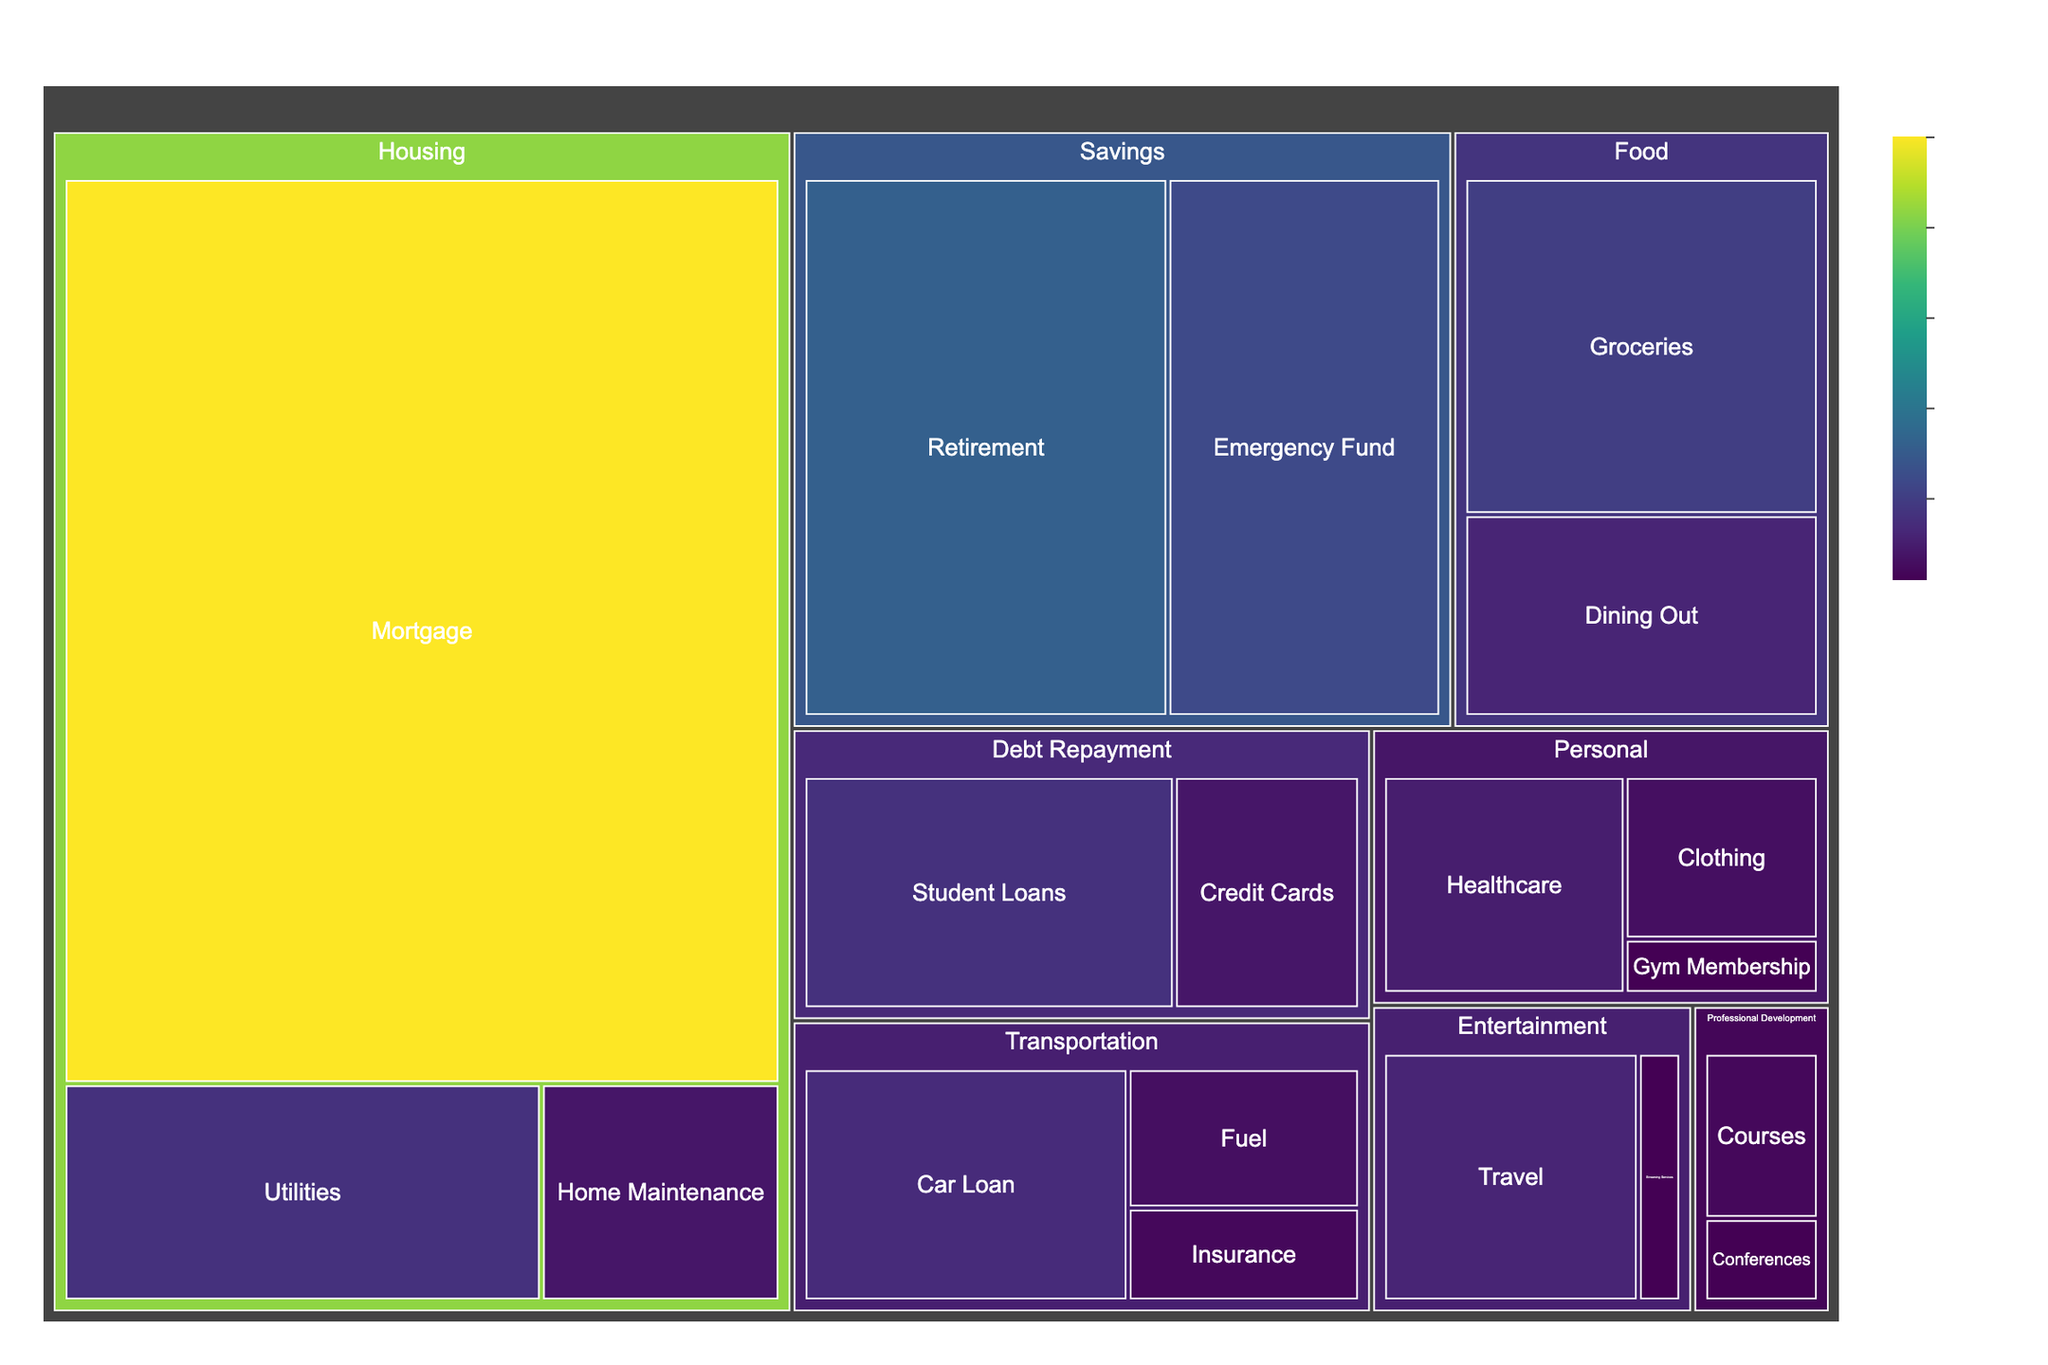What is the largest category in terms of finance allocation? To determine the largest category, look for the segment in the Treemap labeled with the most extensive section. In this case, the largest section is 'Housing.'
Answer: Housing What is the total allocation towards the Housing category? Within the Housing category, sum up the values of all subcategories: Mortgage ($2500), Utilities ($400), and Home Maintenance ($200). The total is 2500 + 400 + 200 = $3100.
Answer: $3100 Which subcategory under Transportation has the lowest allocation? Locate the Transportation category in the Treemap and compare the values of Car Loan ($350), Fuel ($150), and Insurance ($100). The lowest value is Insurance, at $100.
Answer: Insurance What's the combined allocation for Professional Development activities? Add the values for the subcategories 'Courses' ($100) and 'Conferences' ($50) within the Professional Development category. The total is 100 + 50 = $150.
Answer: $150 How does the allocation for Emergency Fund compare to Retirement savings? Look at the subcategories under Savings. Emergency Fund is $600, and Retirement is $800. Retirement savings are higher.
Answer: Retirement ($800) What percentage of the total budget is spent on Entertainment? First, find the total budget by summing up all category values. Then, sum the values for Entertainment (Streaming Services - $50, Travel - $300). Calculate the percentage: (50 + 300) / Total Budget * 100%.
Answer: 4.62% Which subcategory under Debt Repayment has a higher allocation? Compare the subcategories' values: Student Loans ($400) and Credit Cards ($200). Student Loans have a higher allocation.
Answer: Student Loans What is the total amount spent on Personal expenses? Add the values from all subcategories under Personal: Healthcare ($250), Clothing ($150), and Gym Membership ($50). The total is 250 + 150 + 50 = $450.
Answer: $450 Which category, excluding Housing, has the highest allocation? Compare total values of the categories excluding Housing. Savings has the highest allocation with the sum of $600 (Emergency Fund) and $800 (Retirement), which equals $1400.
Answer: Savings 